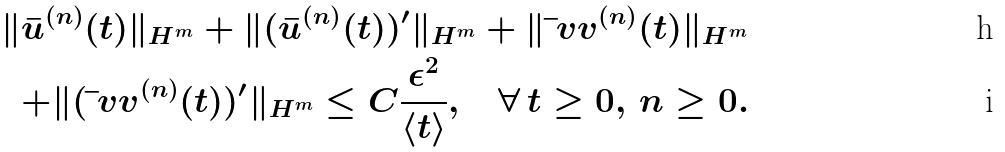<formula> <loc_0><loc_0><loc_500><loc_500>\| \bar { u } ^ { ( n ) } ( t ) \| _ { H ^ { m } } + \| ( \bar { u } ^ { ( n ) } ( t ) ) ^ { \prime } \| _ { H ^ { m } } + \| \bar { \ } v v ^ { ( n ) } ( t ) \| _ { H ^ { m } } \\ + \| ( \bar { \ } v v ^ { ( n ) } ( t ) ) ^ { \prime } \| _ { H ^ { m } } \leq C \frac { \epsilon ^ { 2 } } { \langle t \rangle } , \quad \forall \, t \geq 0 , \, n \geq 0 .</formula> 